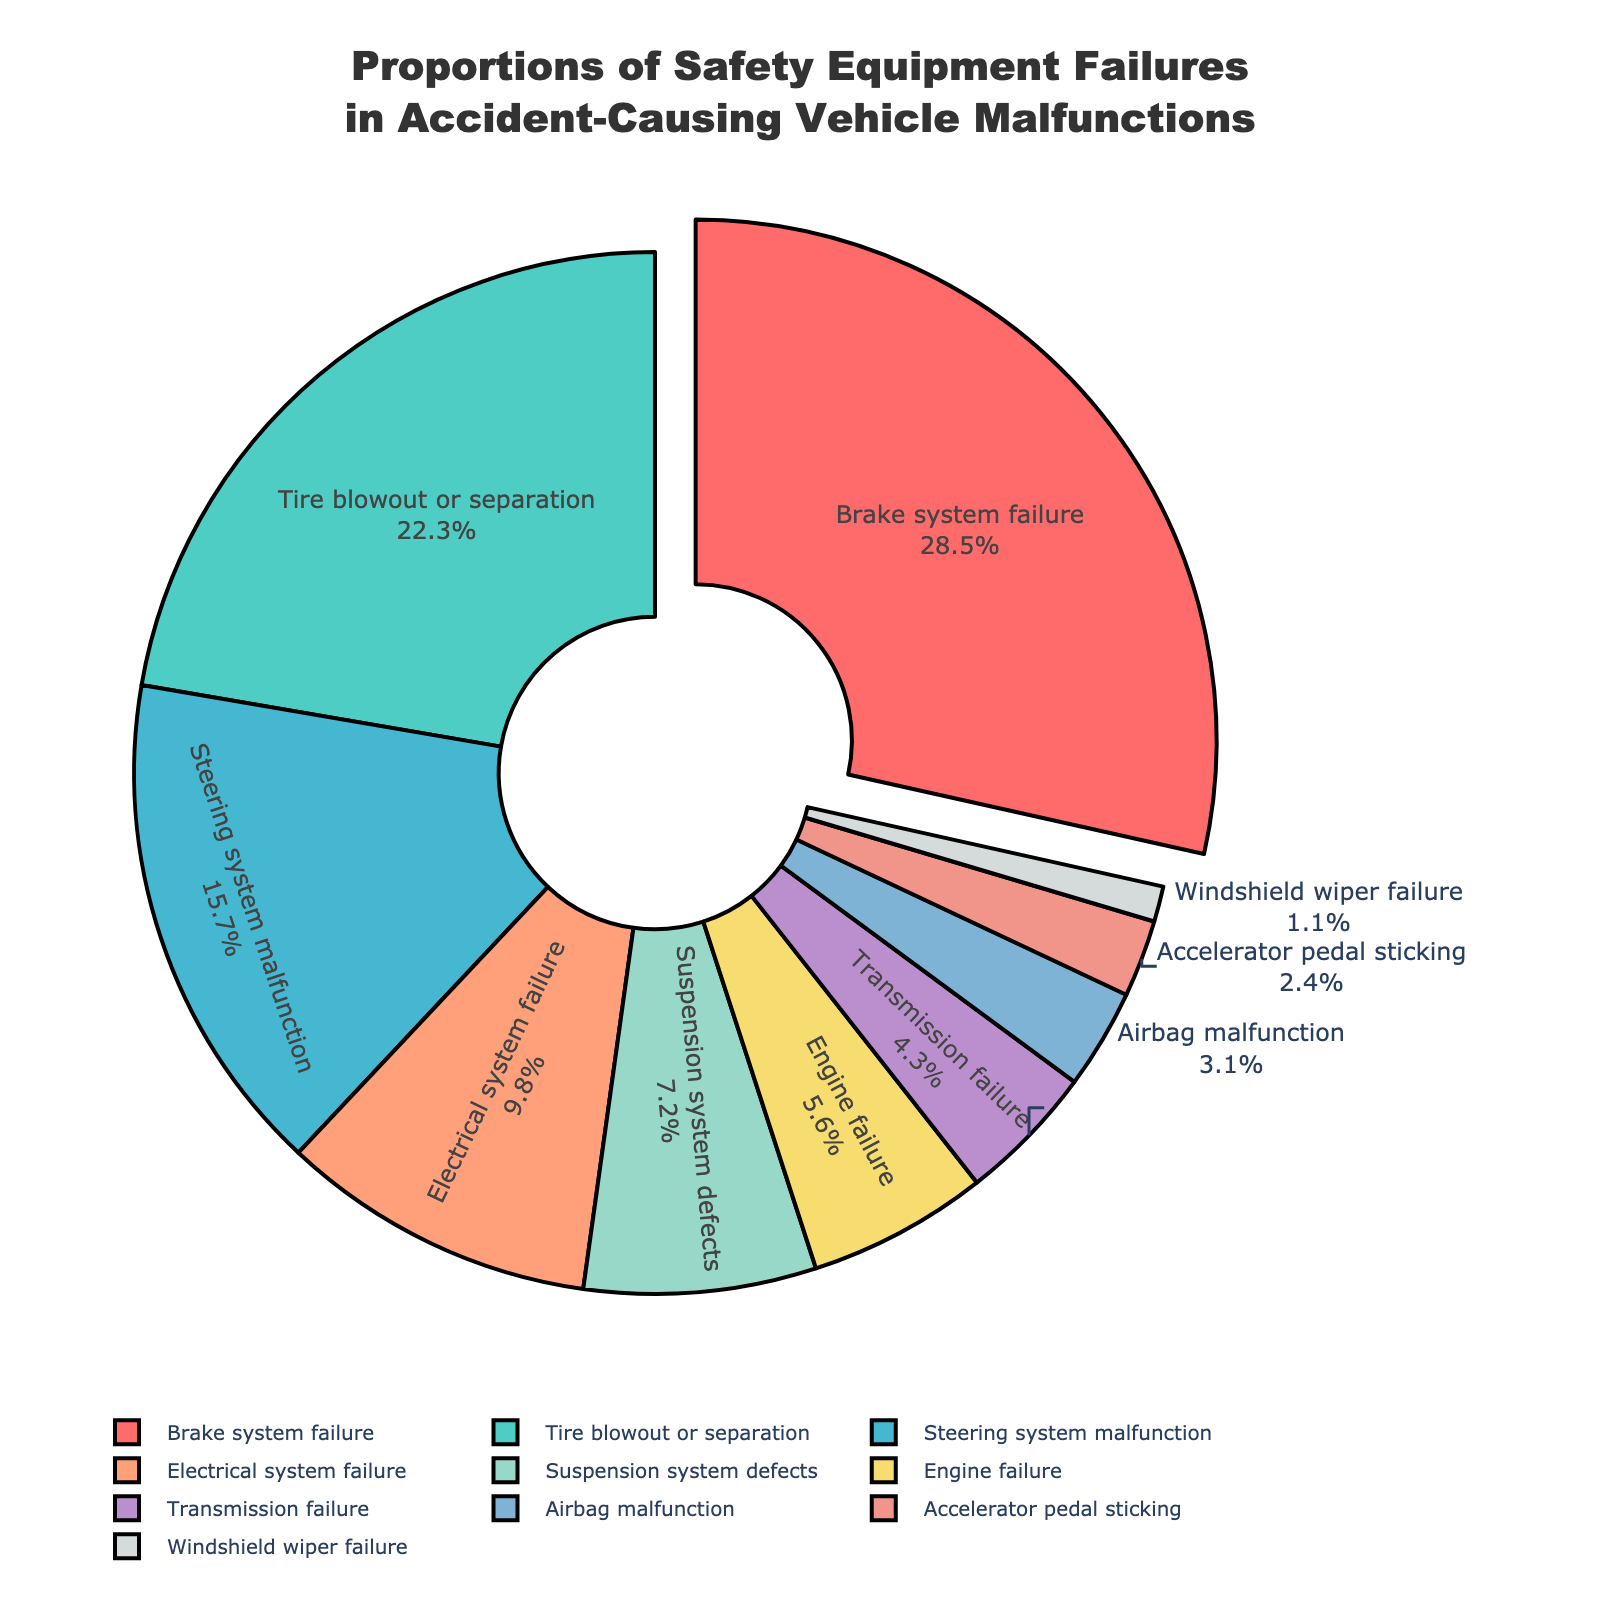Which safety equipment failure has the highest proportion of accident-causing vehicle malfunctions? The portion of the pie chart with the highest percentage is "Brake system failure" at 28.5%, which is visually pulled out for emphasis.
Answer: Brake system failure Compare the proportions of "Tire blowout or separation" and "Steering system malfunction". Which is greater and by how much? "Tire blowout or separation" has a proportion of 22.3%, whereas "Steering system malfunction" has 15.7%. The difference is 22.3% - 15.7% = 6.6%.
Answer: Tire blowout or separation by 6.6% What is the sum of the percentages for "Electrical system failure", "Suspension system defects", and "Engine failure"? Add the percentages for the three categories: 9.8% + 7.2% + 5.6% = 22.6%.
Answer: 22.6% How much larger is the proportion of "Brake system failure" compared to the sum of "Airbag malfunction" and "Accelerator pedal sticking"? The sum of "Airbag malfunction" and "Accelerator pedal sticking" is 3.1% + 2.4% = 5.5%. The difference with "Brake system failure" is 28.5% - 5.5% = 23.0%.
Answer: 23.0% What is the combined percentage of all safety equipment failures that have a proportion less than 5%? Combine the proportions of "Transmission failure" (4.3%), "Airbag malfunction" (3.1%), "Accelerator pedal sticking" (2.4%), and "Windshield wiper failure" (1.1%): 4.3% + 3.1% + 2.4% + 1.1% = 10.9%.
Answer: 10.9% Which categories have proportions closest to 10% and how do their proportions compare? The category closest to 10% is "Electrical system failure" with 9.8%. No other category is close to 10%.
Answer: Electrical system failure is closest at 9.8% What is the difference in proportions between the largest and smallest categories? The largest category is "Brake system failure" at 28.5%, and the smallest is "Windshield wiper failure" at 1.1%. The difference is 28.5% - 1.1% = 27.4%.
Answer: 27.4% Identify all categories that contribute less than 5% to the total. The categories contributing less than 5% are: "Transmission failure" (4.3%), "Airbag malfunction" (3.1%), "Accelerator pedal sticking" (2.4%), and "Windshield wiper failure" (1.1%).
Answer: Transmission failure, Airbag malfunction, Accelerator pedal sticking, Windshield wiper failure 